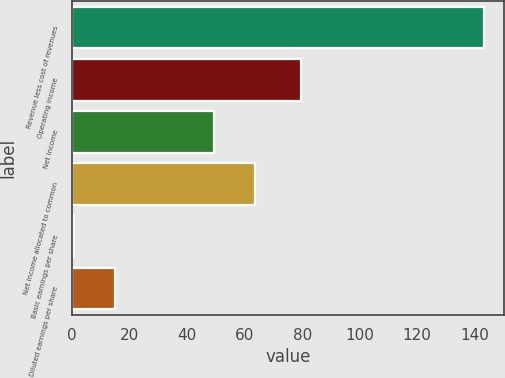Convert chart to OTSL. <chart><loc_0><loc_0><loc_500><loc_500><bar_chart><fcel>Revenue less cost of revenues<fcel>Operating income<fcel>Net income<fcel>Net income allocated to common<fcel>Basic earnings per share<fcel>Diluted earnings per share<nl><fcel>143.1<fcel>79.5<fcel>49.2<fcel>63.45<fcel>0.6<fcel>14.85<nl></chart> 